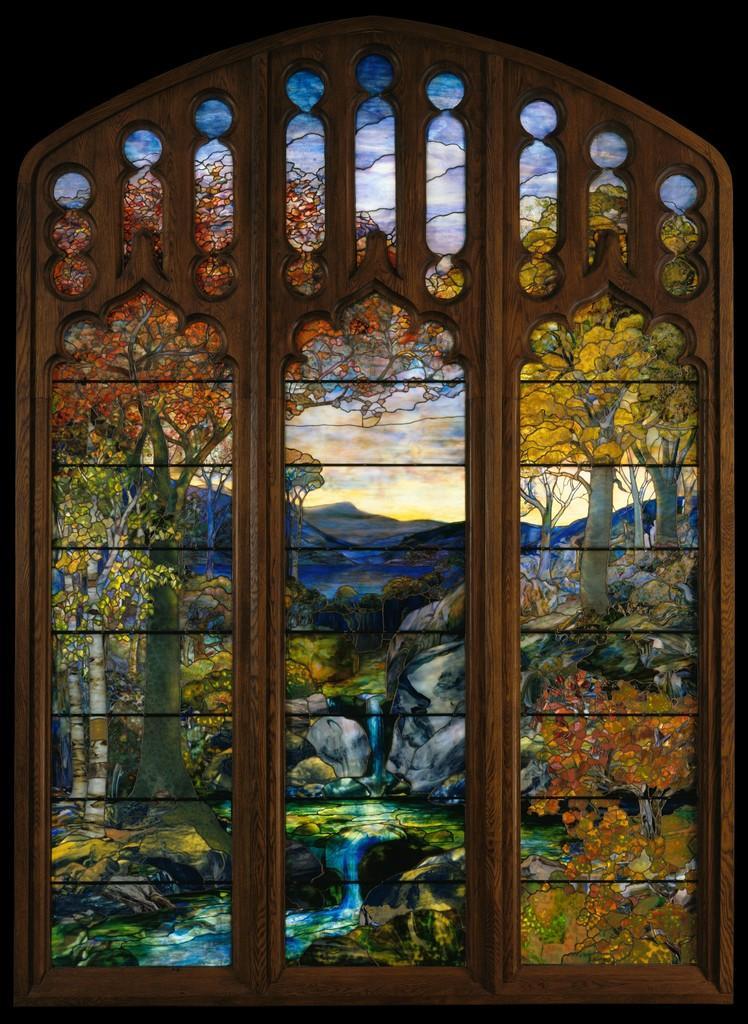In one or two sentences, can you explain what this image depicts? Here we can see a window and a glass. On this class we can see trees, rocks, and sky. 